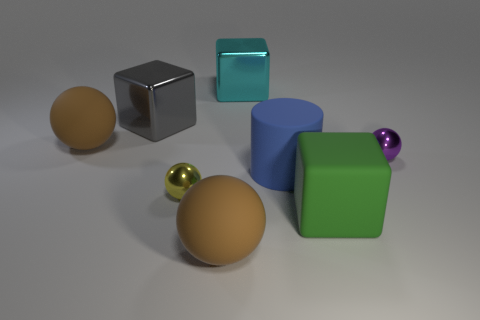Is there anything else that has the same shape as the large blue thing?
Provide a short and direct response. No. What is the brown thing that is behind the metal object to the right of the large object that is to the right of the blue matte object made of?
Make the answer very short. Rubber. Is there a blue thing that has the same size as the cyan object?
Make the answer very short. Yes. What is the color of the rubber thing that is in front of the big green matte cube that is on the left side of the tiny purple sphere?
Make the answer very short. Brown. How many green blocks are there?
Your answer should be compact. 1. Is the number of balls in front of the blue rubber cylinder less than the number of matte things that are right of the gray block?
Give a very brief answer. Yes. The large cylinder has what color?
Offer a very short reply. Blue. How many big spheres have the same color as the large cylinder?
Offer a very short reply. 0. Are there any rubber balls right of the yellow metallic object?
Your response must be concise. Yes. Is the number of tiny purple things in front of the big blue thing the same as the number of tiny purple spheres on the right side of the green rubber object?
Keep it short and to the point. No. 